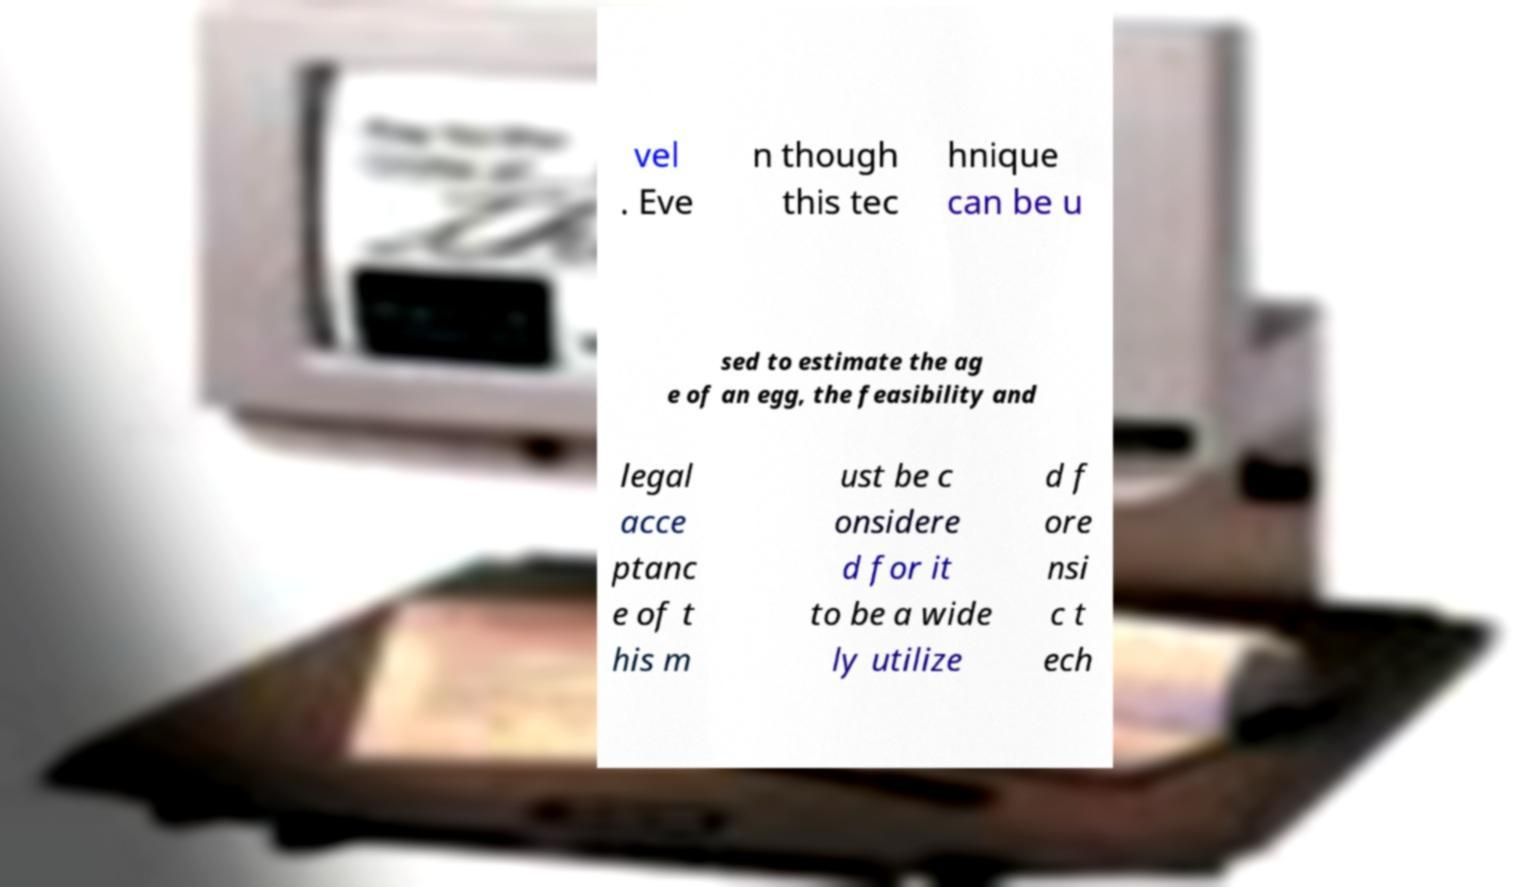I need the written content from this picture converted into text. Can you do that? vel . Eve n though this tec hnique can be u sed to estimate the ag e of an egg, the feasibility and legal acce ptanc e of t his m ust be c onsidere d for it to be a wide ly utilize d f ore nsi c t ech 